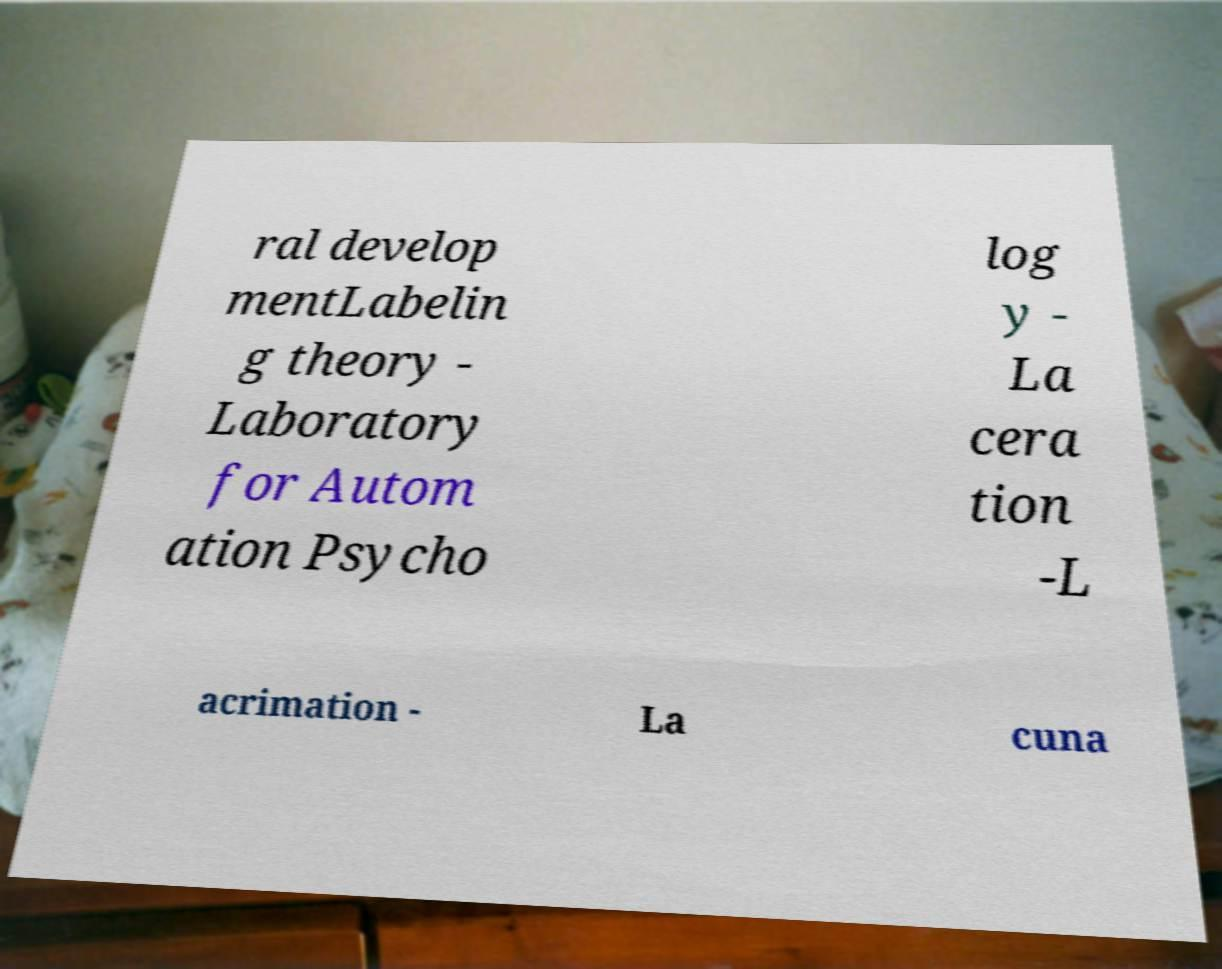There's text embedded in this image that I need extracted. Can you transcribe it verbatim? ral develop mentLabelin g theory - Laboratory for Autom ation Psycho log y - La cera tion -L acrimation - La cuna 